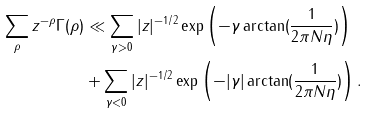Convert formula to latex. <formula><loc_0><loc_0><loc_500><loc_500>\sum _ { \rho } z ^ { - \rho } \Gamma ( \rho ) & \ll \sum _ { \gamma > 0 } | z | ^ { - 1 / 2 } \exp \left ( - \gamma \arctan ( \frac { 1 } { 2 \pi N \eta } ) \right ) \\ & + \sum _ { \gamma < 0 } | z | ^ { - 1 / 2 } \exp \left ( - | \gamma | \arctan ( \frac { 1 } { 2 \pi N \eta } ) \right ) .</formula> 